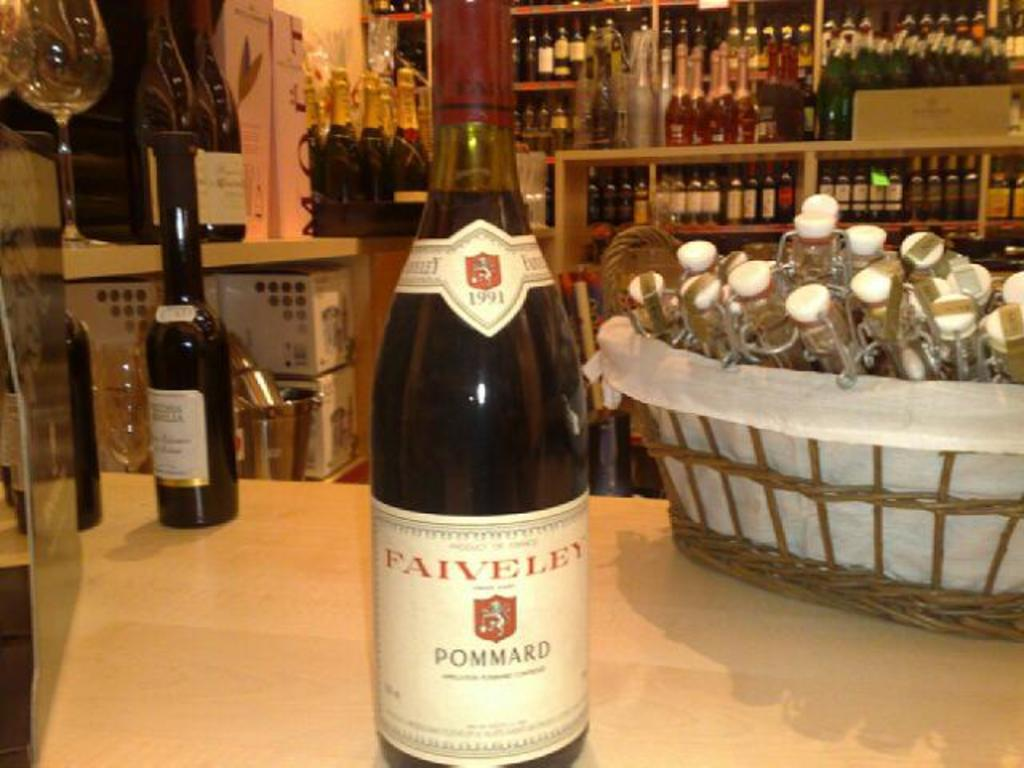Provide a one-sentence caption for the provided image. A bottle of wine from the brand Faiveley. 